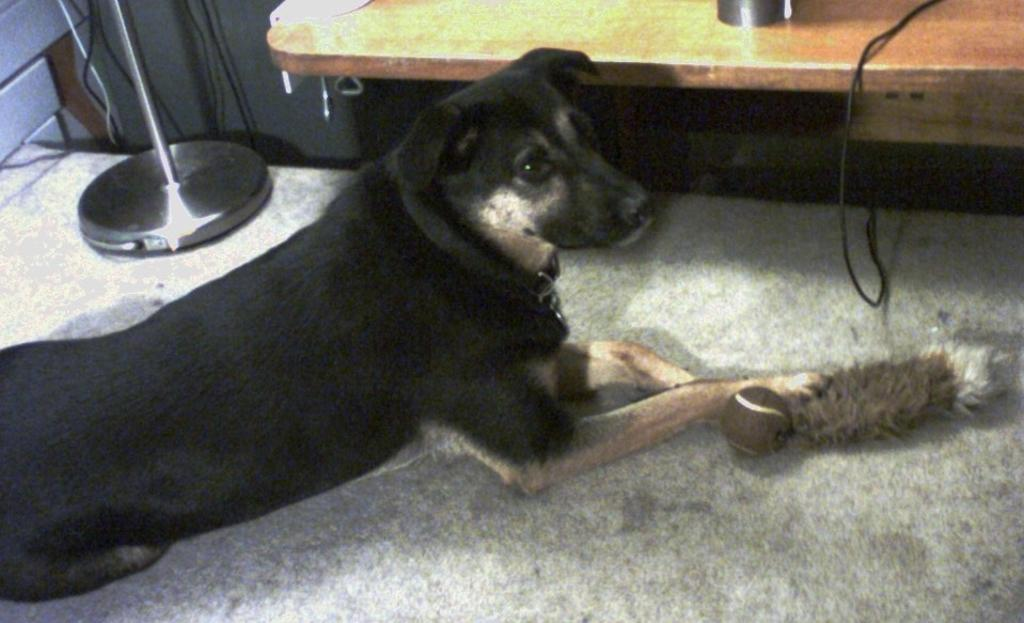What is on the floor in the image? There is a dog on the floor in the image. What else can be seen in the image besides the dog? There are objects in the image. What is visible in the background of the image? There is a stand, wires, and a desk in the background of the image. Can you describe the setting of the image? The image may have been taken in a room. What type of breakfast is the dog eating in the image? There is no breakfast present in the image; it features a dog on the floor and various objects in the background. Who is the writer in the image? There is no writer present in the image. 